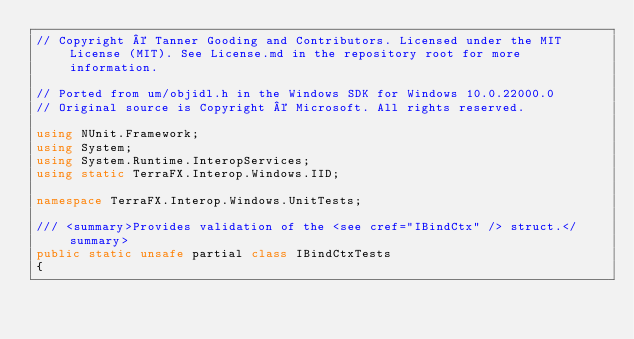Convert code to text. <code><loc_0><loc_0><loc_500><loc_500><_C#_>// Copyright © Tanner Gooding and Contributors. Licensed under the MIT License (MIT). See License.md in the repository root for more information.

// Ported from um/objidl.h in the Windows SDK for Windows 10.0.22000.0
// Original source is Copyright © Microsoft. All rights reserved.

using NUnit.Framework;
using System;
using System.Runtime.InteropServices;
using static TerraFX.Interop.Windows.IID;

namespace TerraFX.Interop.Windows.UnitTests;

/// <summary>Provides validation of the <see cref="IBindCtx" /> struct.</summary>
public static unsafe partial class IBindCtxTests
{</code> 